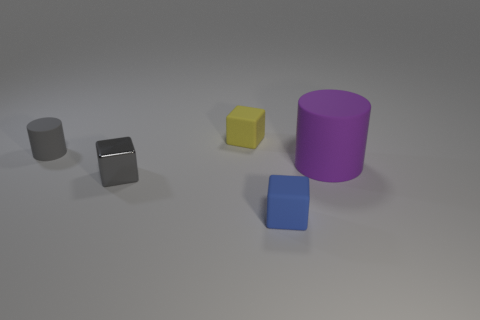What size is the other object that is the same color as the small metal thing?
Give a very brief answer. Small. There is a cylinder that is in front of the rubber object left of the tiny block that is behind the small gray rubber object; what is its color?
Your answer should be compact. Purple. The yellow matte thing that is the same size as the blue rubber object is what shape?
Keep it short and to the point. Cube. Is there anything else that has the same size as the purple rubber thing?
Provide a short and direct response. No. There is a metal block that is left of the tiny yellow cube; does it have the same size as the cylinder that is right of the blue matte thing?
Your answer should be compact. No. How big is the block that is behind the purple cylinder?
Your answer should be very brief. Small. There is a object that is the same color as the small cylinder; what is its material?
Give a very brief answer. Metal. There is a rubber cylinder that is the same size as the gray metallic block; what color is it?
Keep it short and to the point. Gray. Do the gray cylinder and the metal thing have the same size?
Provide a succinct answer. Yes. There is a object that is both in front of the tiny gray cylinder and behind the gray metallic block; how big is it?
Offer a very short reply. Large. 